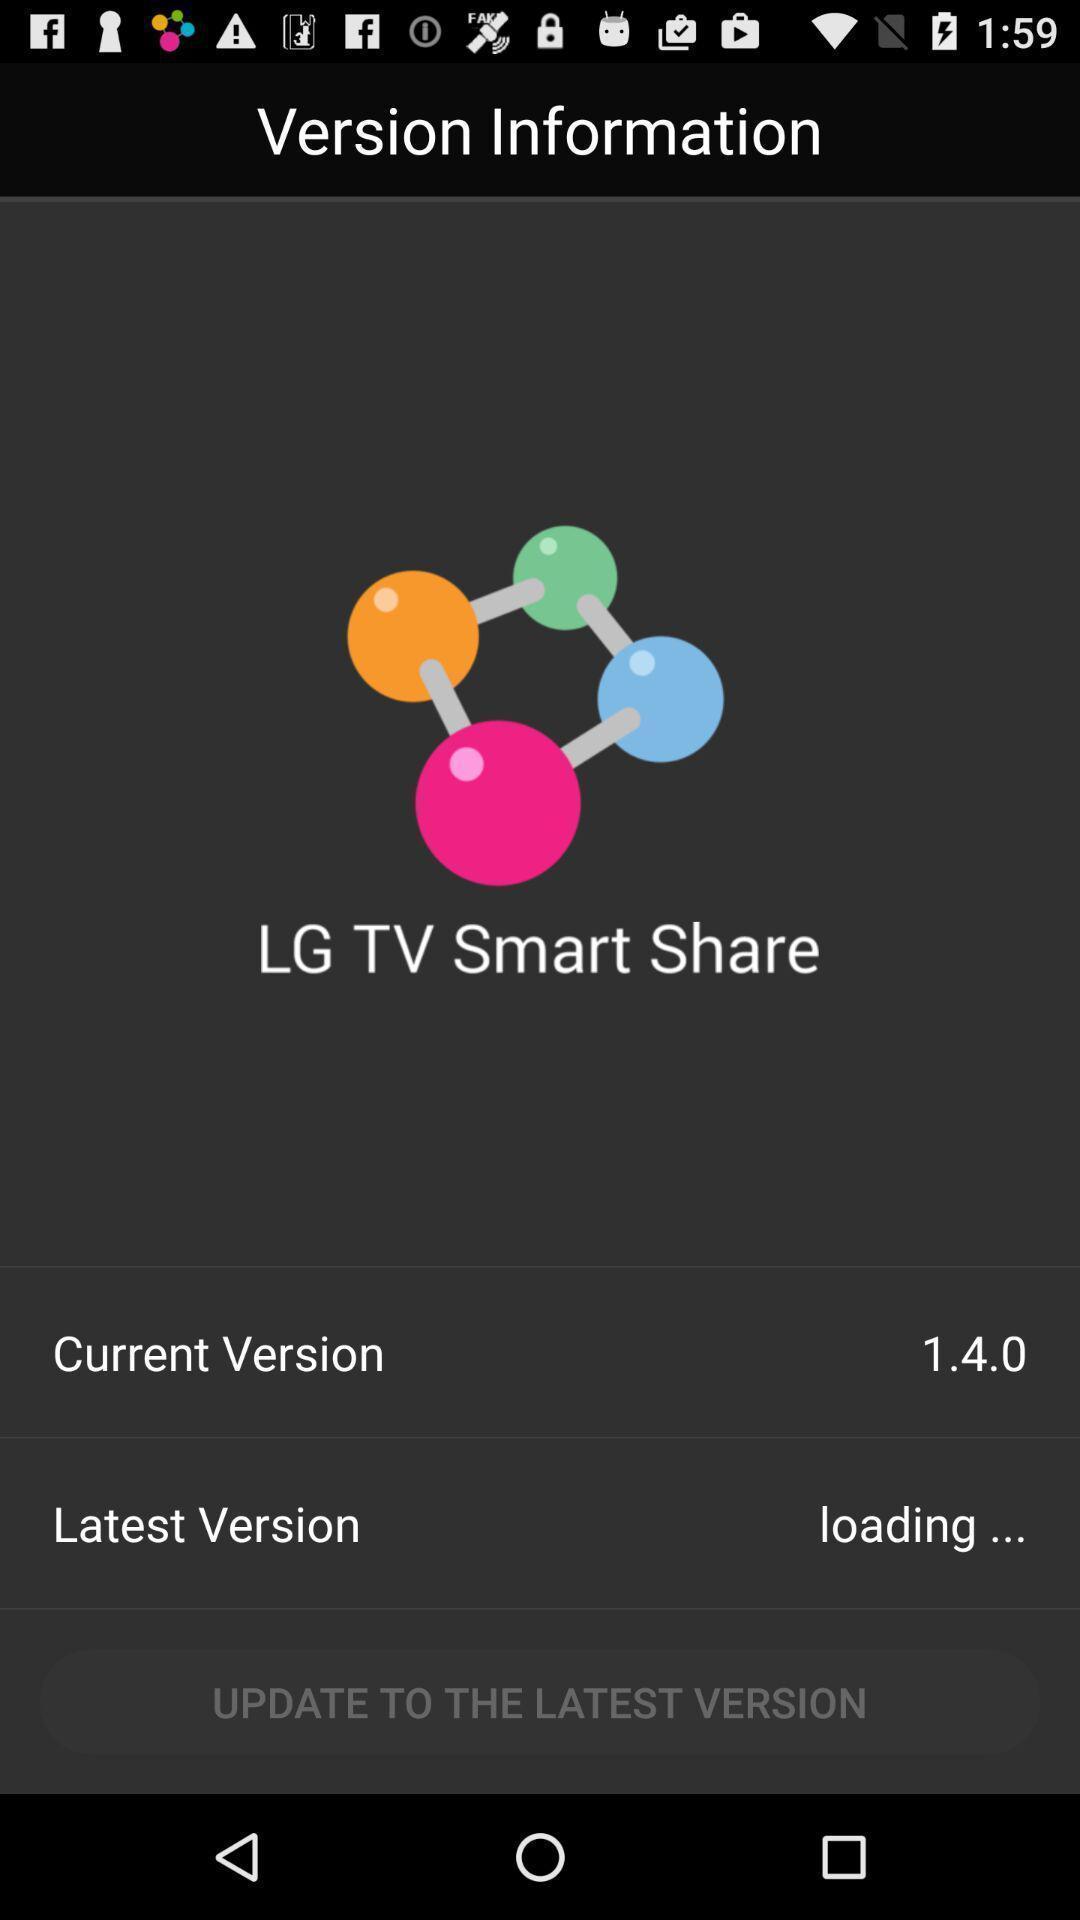Tell me what you see in this picture. Page showing version details. 